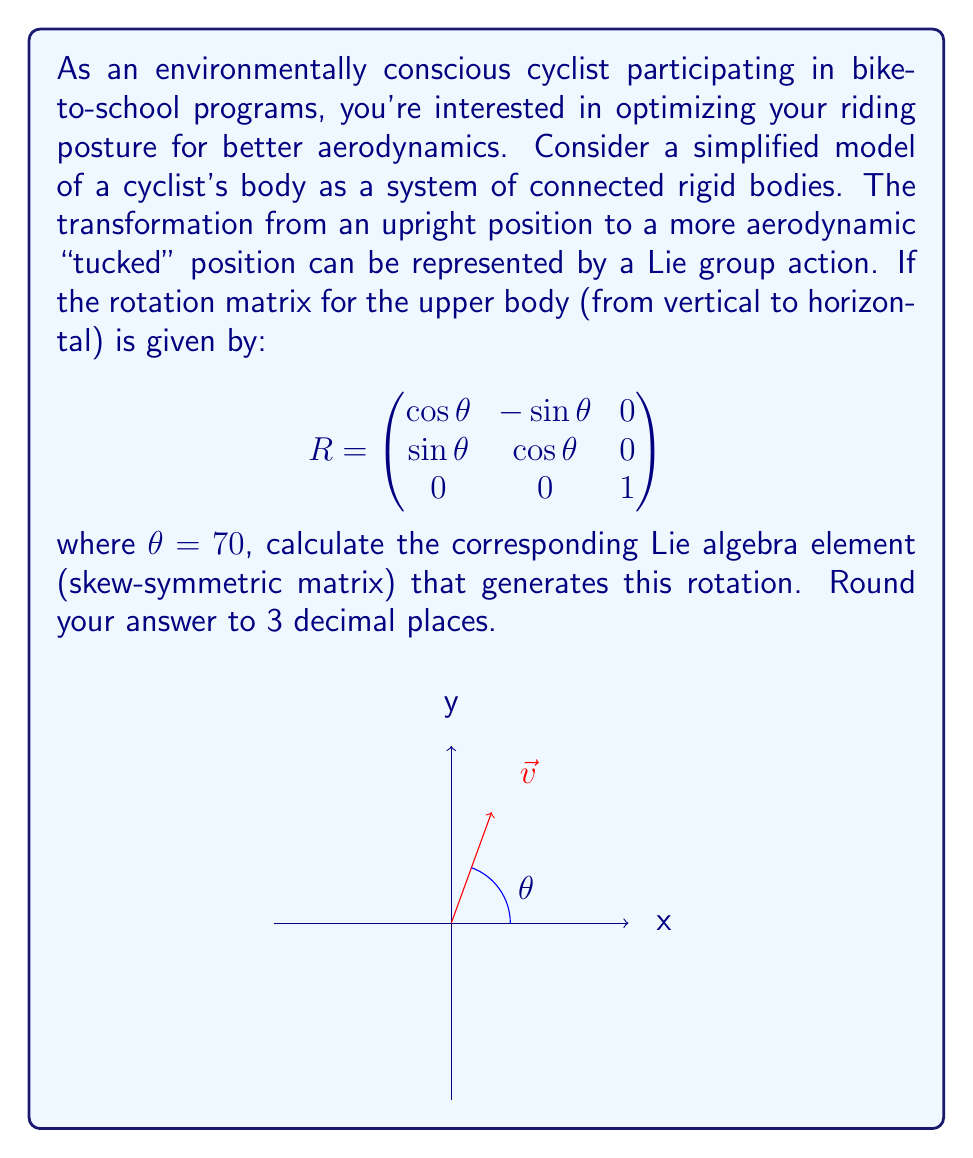Show me your answer to this math problem. Let's approach this step-by-step:

1) The Lie algebra element corresponding to a rotation matrix is the matrix logarithm of the rotation matrix. For a rotation in 3D, this Lie algebra element is a skew-symmetric matrix of the form:

   $$\omega = \begin{pmatrix}
   0 & -\omega_z & \omega_y \\
   \omega_z & 0 & -\omega_x \\
   -\omega_y & \omega_x & 0
   \end{pmatrix}$$

2) For a rotation around the z-axis (which is our case), only $\omega_z$ is non-zero. We can find $\omega_z$ using the formula:

   $$\omega_z = \frac{\theta}{\sin\theta} (R_{21})$$

   where $R_{21}$ is the element in the second row, first column of the rotation matrix.

3) We're given $\theta = 70°$. Let's convert this to radians:

   $$\theta = 70° \times \frac{\pi}{180°} \approx 1.2217 \text{ radians}$$

4) Now we can calculate $\sin\theta$:

   $$\sin\theta \approx 0.9397$$

5) From the given rotation matrix, we can see that $R_{21} = \sin\theta$. So:

   $$\omega_z = \frac{1.2217}{0.9397} \times 0.9397 = 1.2217$$

6) Therefore, our Lie algebra element is:

   $$\omega = \begin{pmatrix}
   0 & -1.2217 & 0 \\
   1.2217 & 0 & 0 \\
   0 & 0 & 0
   \end{pmatrix}$$

7) Rounding to 3 decimal places:

   $$\omega \approx \begin{pmatrix}
   0 & -1.222 & 0 \\
   1.222 & 0 & 0 \\
   0 & 0 & 0
   \end{pmatrix}$$
Answer: $$\begin{pmatrix}
0 & -1.222 & 0 \\
1.222 & 0 & 0 \\
0 & 0 & 0
\end{pmatrix}$$ 